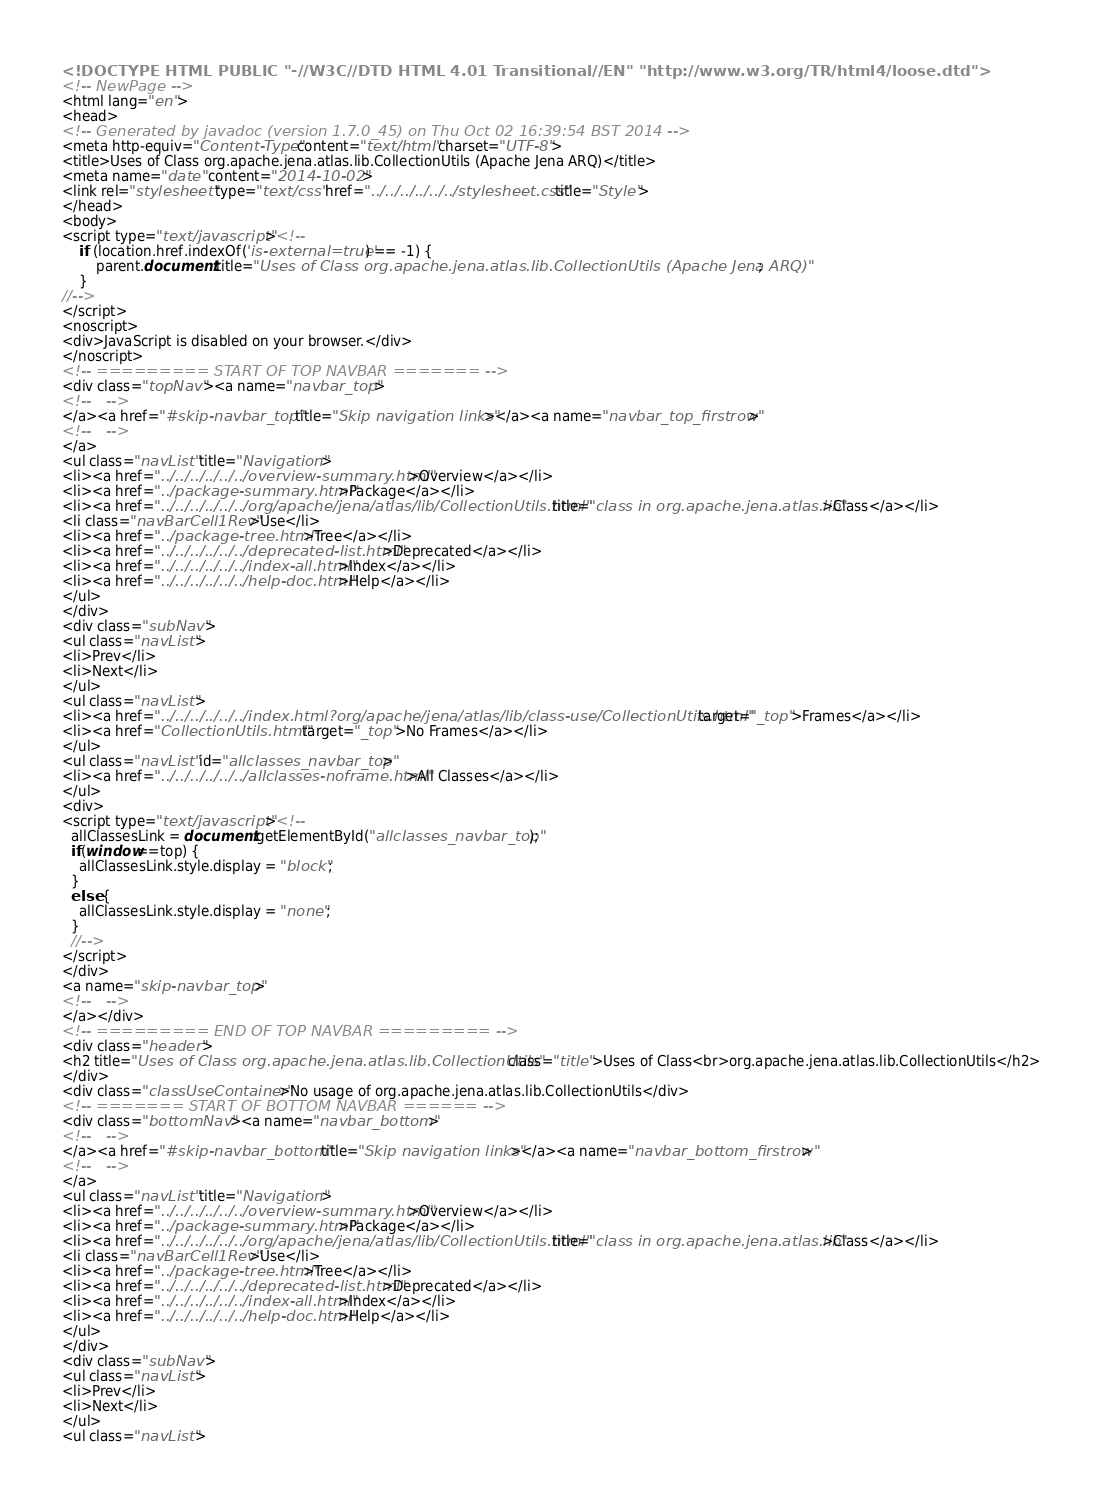Convert code to text. <code><loc_0><loc_0><loc_500><loc_500><_HTML_><!DOCTYPE HTML PUBLIC "-//W3C//DTD HTML 4.01 Transitional//EN" "http://www.w3.org/TR/html4/loose.dtd">
<!-- NewPage -->
<html lang="en">
<head>
<!-- Generated by javadoc (version 1.7.0_45) on Thu Oct 02 16:39:54 BST 2014 -->
<meta http-equiv="Content-Type" content="text/html" charset="UTF-8">
<title>Uses of Class org.apache.jena.atlas.lib.CollectionUtils (Apache Jena ARQ)</title>
<meta name="date" content="2014-10-02">
<link rel="stylesheet" type="text/css" href="../../../../../../stylesheet.css" title="Style">
</head>
<body>
<script type="text/javascript"><!--
    if (location.href.indexOf('is-external=true') == -1) {
        parent.document.title="Uses of Class org.apache.jena.atlas.lib.CollectionUtils (Apache Jena ARQ)";
    }
//-->
</script>
<noscript>
<div>JavaScript is disabled on your browser.</div>
</noscript>
<!-- ========= START OF TOP NAVBAR ======= -->
<div class="topNav"><a name="navbar_top">
<!--   -->
</a><a href="#skip-navbar_top" title="Skip navigation links"></a><a name="navbar_top_firstrow">
<!--   -->
</a>
<ul class="navList" title="Navigation">
<li><a href="../../../../../../overview-summary.html">Overview</a></li>
<li><a href="../package-summary.html">Package</a></li>
<li><a href="../../../../../../org/apache/jena/atlas/lib/CollectionUtils.html" title="class in org.apache.jena.atlas.lib">Class</a></li>
<li class="navBarCell1Rev">Use</li>
<li><a href="../package-tree.html">Tree</a></li>
<li><a href="../../../../../../deprecated-list.html">Deprecated</a></li>
<li><a href="../../../../../../index-all.html">Index</a></li>
<li><a href="../../../../../../help-doc.html">Help</a></li>
</ul>
</div>
<div class="subNav">
<ul class="navList">
<li>Prev</li>
<li>Next</li>
</ul>
<ul class="navList">
<li><a href="../../../../../../index.html?org/apache/jena/atlas/lib/class-use/CollectionUtils.html" target="_top">Frames</a></li>
<li><a href="CollectionUtils.html" target="_top">No Frames</a></li>
</ul>
<ul class="navList" id="allclasses_navbar_top">
<li><a href="../../../../../../allclasses-noframe.html">All Classes</a></li>
</ul>
<div>
<script type="text/javascript"><!--
  allClassesLink = document.getElementById("allclasses_navbar_top");
  if(window==top) {
    allClassesLink.style.display = "block";
  }
  else {
    allClassesLink.style.display = "none";
  }
  //-->
</script>
</div>
<a name="skip-navbar_top">
<!--   -->
</a></div>
<!-- ========= END OF TOP NAVBAR ========= -->
<div class="header">
<h2 title="Uses of Class org.apache.jena.atlas.lib.CollectionUtils" class="title">Uses of Class<br>org.apache.jena.atlas.lib.CollectionUtils</h2>
</div>
<div class="classUseContainer">No usage of org.apache.jena.atlas.lib.CollectionUtils</div>
<!-- ======= START OF BOTTOM NAVBAR ====== -->
<div class="bottomNav"><a name="navbar_bottom">
<!--   -->
</a><a href="#skip-navbar_bottom" title="Skip navigation links"></a><a name="navbar_bottom_firstrow">
<!--   -->
</a>
<ul class="navList" title="Navigation">
<li><a href="../../../../../../overview-summary.html">Overview</a></li>
<li><a href="../package-summary.html">Package</a></li>
<li><a href="../../../../../../org/apache/jena/atlas/lib/CollectionUtils.html" title="class in org.apache.jena.atlas.lib">Class</a></li>
<li class="navBarCell1Rev">Use</li>
<li><a href="../package-tree.html">Tree</a></li>
<li><a href="../../../../../../deprecated-list.html">Deprecated</a></li>
<li><a href="../../../../../../index-all.html">Index</a></li>
<li><a href="../../../../../../help-doc.html">Help</a></li>
</ul>
</div>
<div class="subNav">
<ul class="navList">
<li>Prev</li>
<li>Next</li>
</ul>
<ul class="navList"></code> 